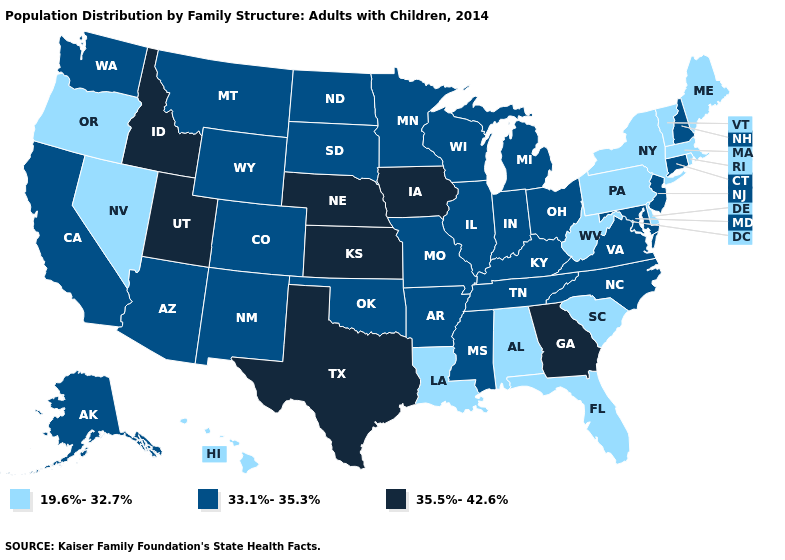What is the value of Rhode Island?
Answer briefly. 19.6%-32.7%. What is the value of Minnesota?
Keep it brief. 33.1%-35.3%. Name the states that have a value in the range 33.1%-35.3%?
Give a very brief answer. Alaska, Arizona, Arkansas, California, Colorado, Connecticut, Illinois, Indiana, Kentucky, Maryland, Michigan, Minnesota, Mississippi, Missouri, Montana, New Hampshire, New Jersey, New Mexico, North Carolina, North Dakota, Ohio, Oklahoma, South Dakota, Tennessee, Virginia, Washington, Wisconsin, Wyoming. What is the value of North Dakota?
Quick response, please. 33.1%-35.3%. What is the lowest value in the West?
Short answer required. 19.6%-32.7%. What is the value of Vermont?
Short answer required. 19.6%-32.7%. Name the states that have a value in the range 33.1%-35.3%?
Quick response, please. Alaska, Arizona, Arkansas, California, Colorado, Connecticut, Illinois, Indiana, Kentucky, Maryland, Michigan, Minnesota, Mississippi, Missouri, Montana, New Hampshire, New Jersey, New Mexico, North Carolina, North Dakota, Ohio, Oklahoma, South Dakota, Tennessee, Virginia, Washington, Wisconsin, Wyoming. Name the states that have a value in the range 33.1%-35.3%?
Write a very short answer. Alaska, Arizona, Arkansas, California, Colorado, Connecticut, Illinois, Indiana, Kentucky, Maryland, Michigan, Minnesota, Mississippi, Missouri, Montana, New Hampshire, New Jersey, New Mexico, North Carolina, North Dakota, Ohio, Oklahoma, South Dakota, Tennessee, Virginia, Washington, Wisconsin, Wyoming. Does the map have missing data?
Short answer required. No. Name the states that have a value in the range 19.6%-32.7%?
Concise answer only. Alabama, Delaware, Florida, Hawaii, Louisiana, Maine, Massachusetts, Nevada, New York, Oregon, Pennsylvania, Rhode Island, South Carolina, Vermont, West Virginia. What is the value of California?
Keep it brief. 33.1%-35.3%. Which states have the lowest value in the USA?
Give a very brief answer. Alabama, Delaware, Florida, Hawaii, Louisiana, Maine, Massachusetts, Nevada, New York, Oregon, Pennsylvania, Rhode Island, South Carolina, Vermont, West Virginia. What is the lowest value in the USA?
Concise answer only. 19.6%-32.7%. 